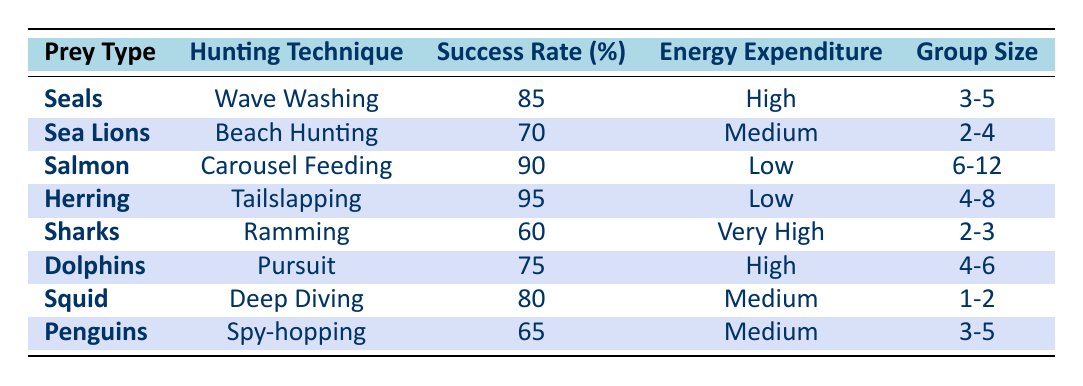What is the success rate for hunting Herring? The table explicitly states that the success rate for hunting Herring is 95%.
Answer: 95 Which hunting technique has the highest success rate? By examining the success rates listed in the table, we find that Tailslapping for Herring has the highest success rate at 95%.
Answer: Tailslapping Is the energy expenditure for hunting Sharks categorized as high? The table shows that the energy expenditure for hunting Sharks is labeled as "Very High," which means it is not categorized as high.
Answer: No What is the average success rate for all the hunting techniques listed? The success rates are 85, 70, 90, 95, 60, 75, 80, and 65. Adding these gives a total of 750, dividing by 8 gives an average of 750/8 = 93.75.
Answer: 93.75 How many hunting techniques have a "Low" energy expenditure? By reviewing the table, the hunting techniques with "Low" energy expenditure are Carousel Feeding (Salmon) and Tailslapping (Herring), totaling 2.
Answer: 2 Which prey type has the highest energy expenditure, and what is that expenditure? Looking at the table, Sharks have the highest energy expenditure, which is categorized as "Very High." However, it cannot be quantified so simply as a numerical value is not provided.
Answer: Very High Is the group size for hunting Sea Lions typically larger than that for hunting Penguins? The group size for hunting Sea Lions is 2-4, whereas for Penguins, it is 3-5. Thus, the range for Sea Lions does not exceed that for Penguins.
Answer: No Which hunting technique has the highest success rate for a group size of 3-5? For a group size of 3-5, the hunting techniques that apply are Wave Washing (Seals), Spy-hopping (Penguins), and Carousel Feeding (Salmon). Among these, Wave Washing has the highest success rate of 85%.
Answer: Wave Washing 